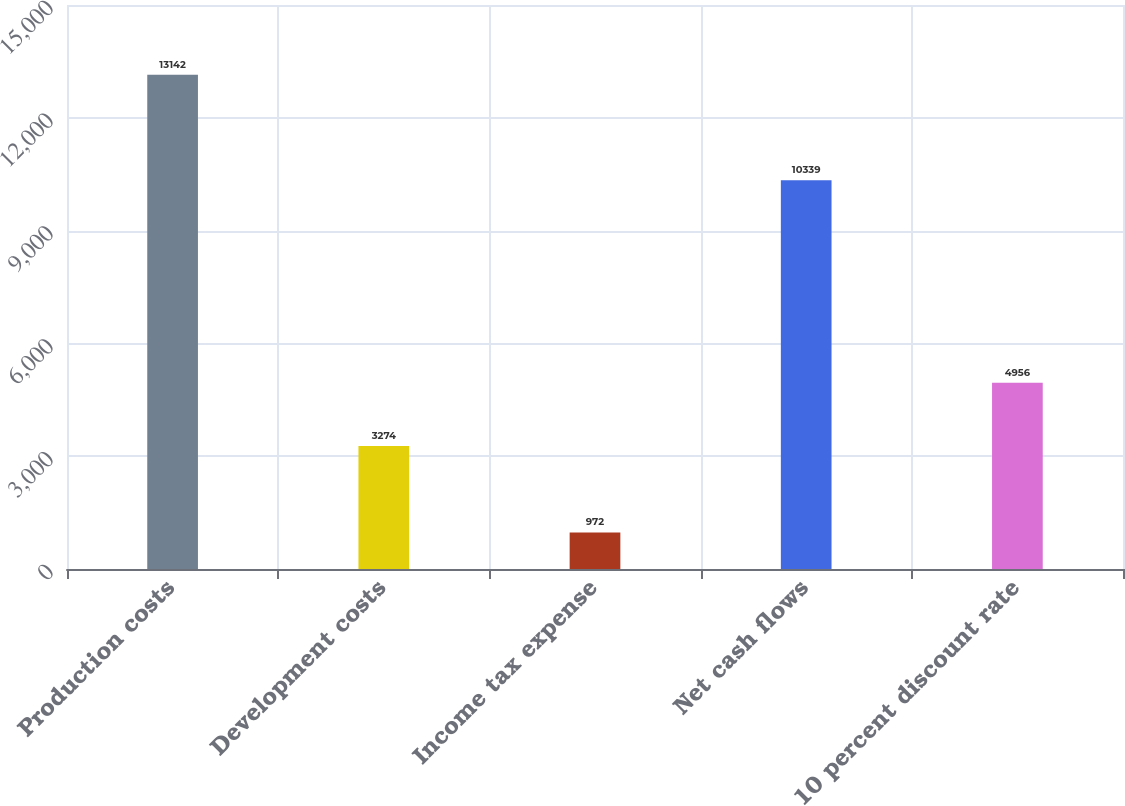<chart> <loc_0><loc_0><loc_500><loc_500><bar_chart><fcel>Production costs<fcel>Development costs<fcel>Income tax expense<fcel>Net cash flows<fcel>10 percent discount rate<nl><fcel>13142<fcel>3274<fcel>972<fcel>10339<fcel>4956<nl></chart> 